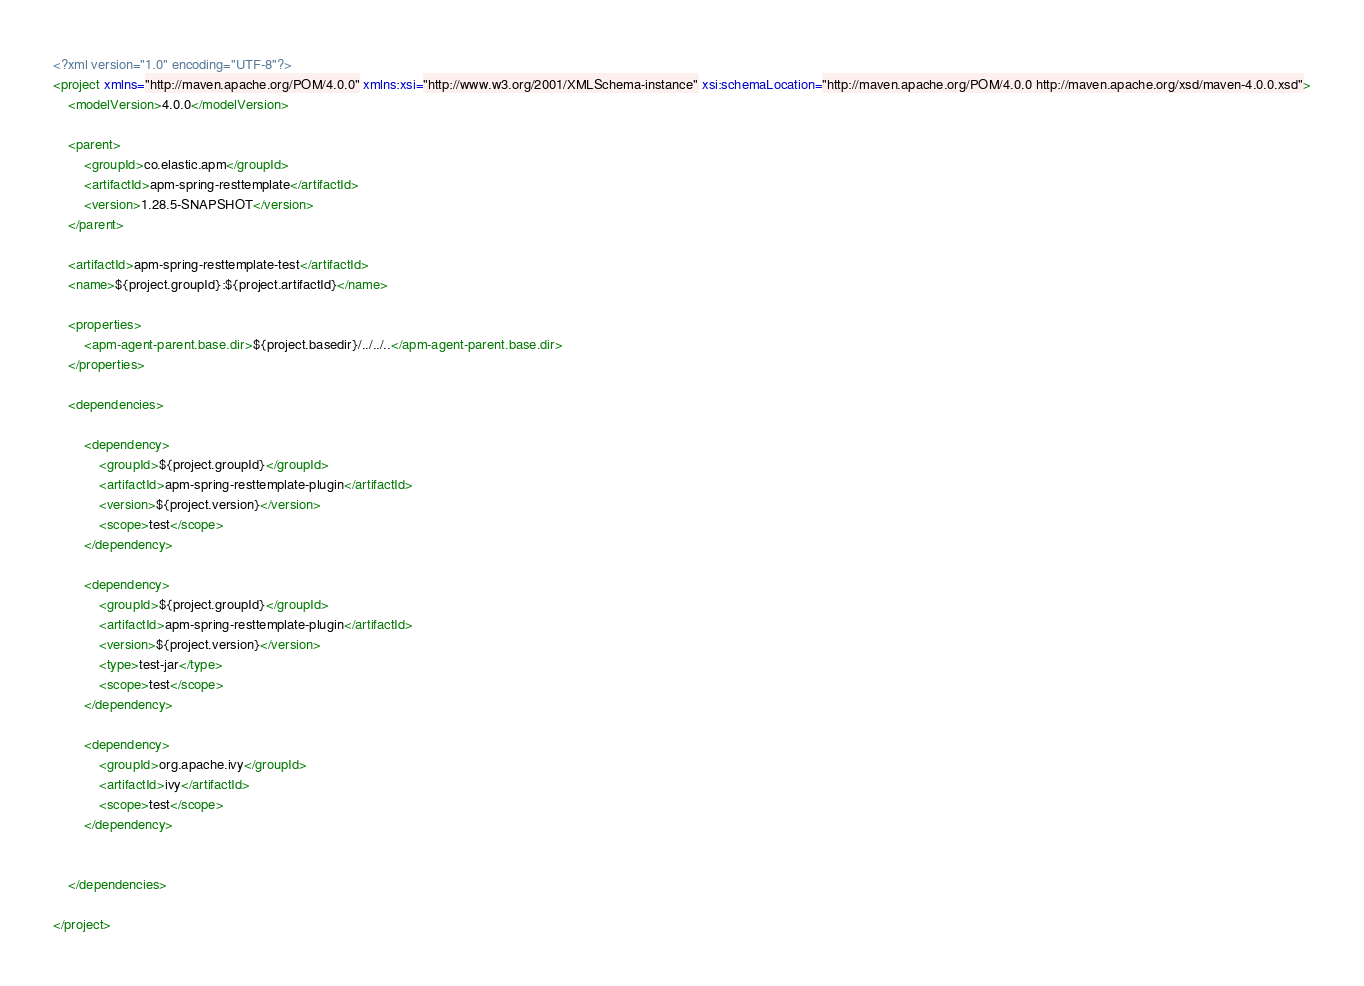<code> <loc_0><loc_0><loc_500><loc_500><_XML_><?xml version="1.0" encoding="UTF-8"?>
<project xmlns="http://maven.apache.org/POM/4.0.0" xmlns:xsi="http://www.w3.org/2001/XMLSchema-instance" xsi:schemaLocation="http://maven.apache.org/POM/4.0.0 http://maven.apache.org/xsd/maven-4.0.0.xsd">
    <modelVersion>4.0.0</modelVersion>

    <parent>
        <groupId>co.elastic.apm</groupId>
        <artifactId>apm-spring-resttemplate</artifactId>
        <version>1.28.5-SNAPSHOT</version>
    </parent>

    <artifactId>apm-spring-resttemplate-test</artifactId>
    <name>${project.groupId}:${project.artifactId}</name>

    <properties>
        <apm-agent-parent.base.dir>${project.basedir}/../../..</apm-agent-parent.base.dir>
    </properties>

    <dependencies>

        <dependency>
            <groupId>${project.groupId}</groupId>
            <artifactId>apm-spring-resttemplate-plugin</artifactId>
            <version>${project.version}</version>
            <scope>test</scope>
        </dependency>

        <dependency>
            <groupId>${project.groupId}</groupId>
            <artifactId>apm-spring-resttemplate-plugin</artifactId>
            <version>${project.version}</version>
            <type>test-jar</type>
            <scope>test</scope>
        </dependency>

        <dependency>
            <groupId>org.apache.ivy</groupId>
            <artifactId>ivy</artifactId>
            <scope>test</scope>
        </dependency>


    </dependencies>

</project>
</code> 